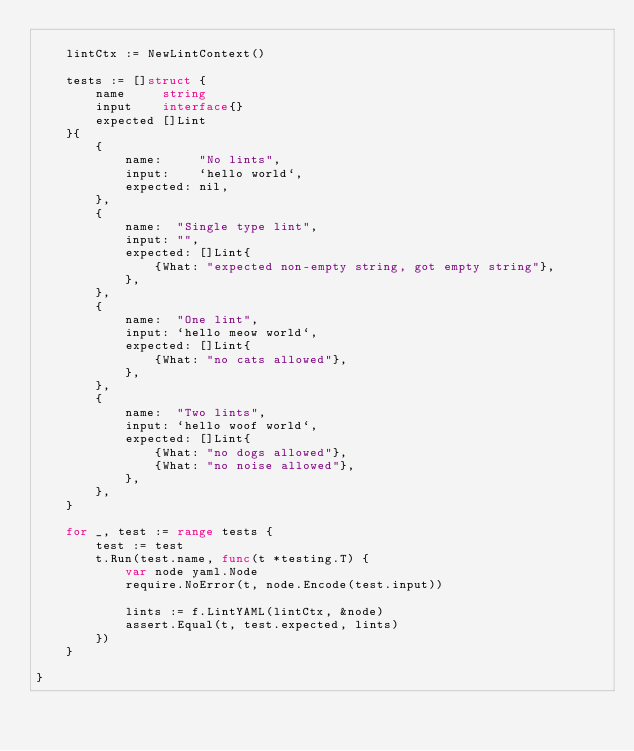<code> <loc_0><loc_0><loc_500><loc_500><_Go_>
	lintCtx := NewLintContext()

	tests := []struct {
		name     string
		input    interface{}
		expected []Lint
	}{
		{
			name:     "No lints",
			input:    `hello world`,
			expected: nil,
		},
		{
			name:  "Single type lint",
			input: "",
			expected: []Lint{
				{What: "expected non-empty string, got empty string"},
			},
		},
		{
			name:  "One lint",
			input: `hello meow world`,
			expected: []Lint{
				{What: "no cats allowed"},
			},
		},
		{
			name:  "Two lints",
			input: `hello woof world`,
			expected: []Lint{
				{What: "no dogs allowed"},
				{What: "no noise allowed"},
			},
		},
	}

	for _, test := range tests {
		test := test
		t.Run(test.name, func(t *testing.T) {
			var node yaml.Node
			require.NoError(t, node.Encode(test.input))

			lints := f.LintYAML(lintCtx, &node)
			assert.Equal(t, test.expected, lints)
		})
	}

}
</code> 